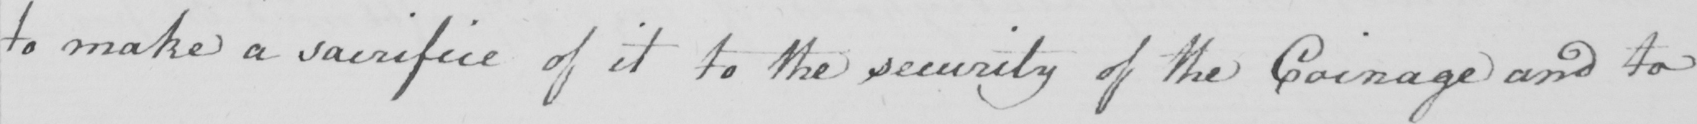Transcribe the text shown in this historical manuscript line. to make a sacrifice of it to the security of the Coinage and to 